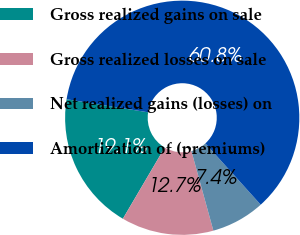Convert chart to OTSL. <chart><loc_0><loc_0><loc_500><loc_500><pie_chart><fcel>Gross realized gains on sale<fcel>Gross realized losses on sale<fcel>Net realized gains (losses) on<fcel>Amortization of (premiums)<nl><fcel>19.07%<fcel>12.74%<fcel>7.4%<fcel>60.78%<nl></chart> 